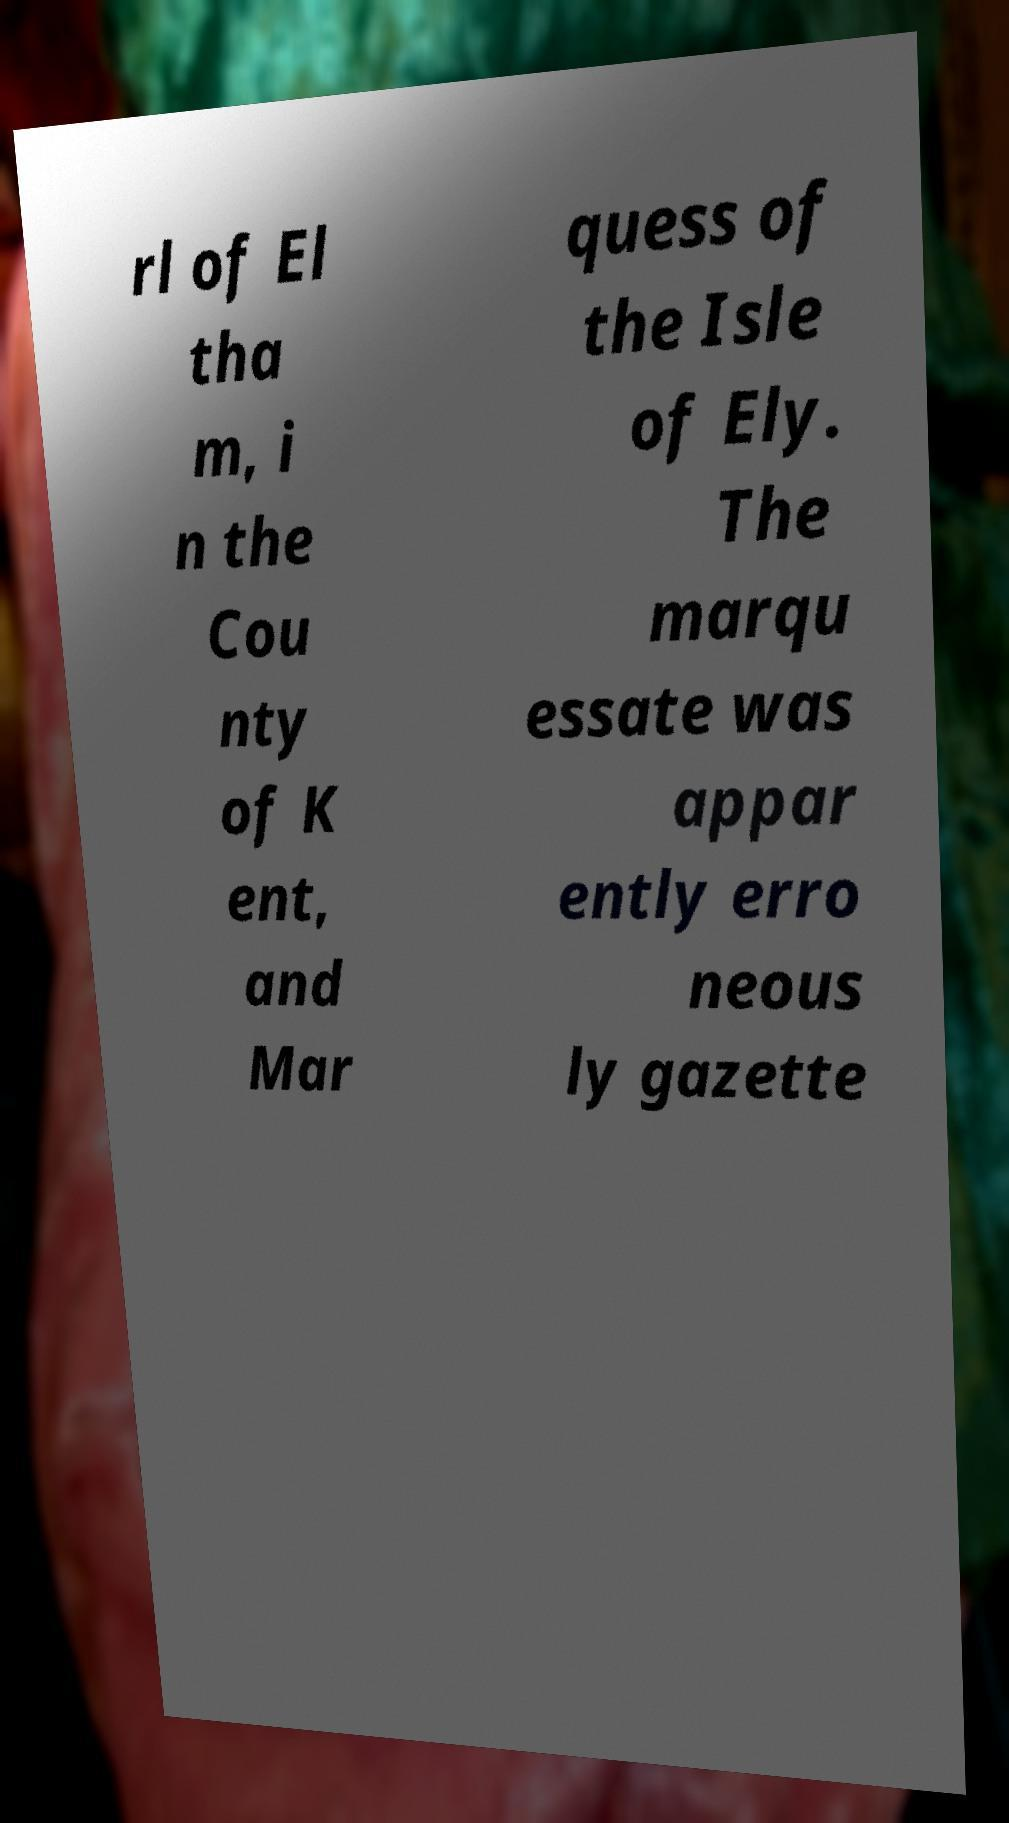Please read and relay the text visible in this image. What does it say? rl of El tha m, i n the Cou nty of K ent, and Mar quess of the Isle of Ely. The marqu essate was appar ently erro neous ly gazette 